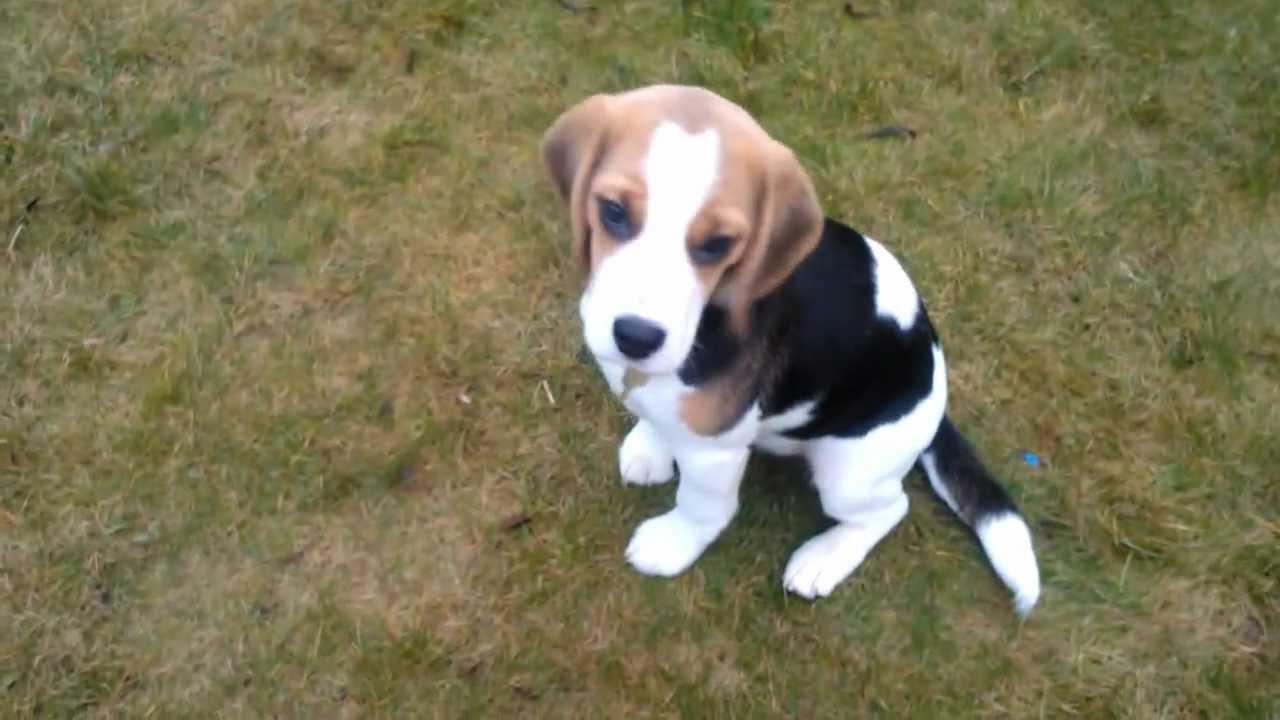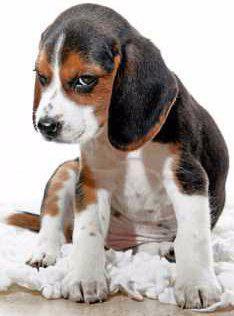The first image is the image on the left, the second image is the image on the right. For the images displayed, is the sentence "One dog is chewing on something." factually correct? Answer yes or no. No. The first image is the image on the left, the second image is the image on the right. Considering the images on both sides, is "Each image shows one young beagle, and no beagle is in a reclining pose." valid? Answer yes or no. Yes. 